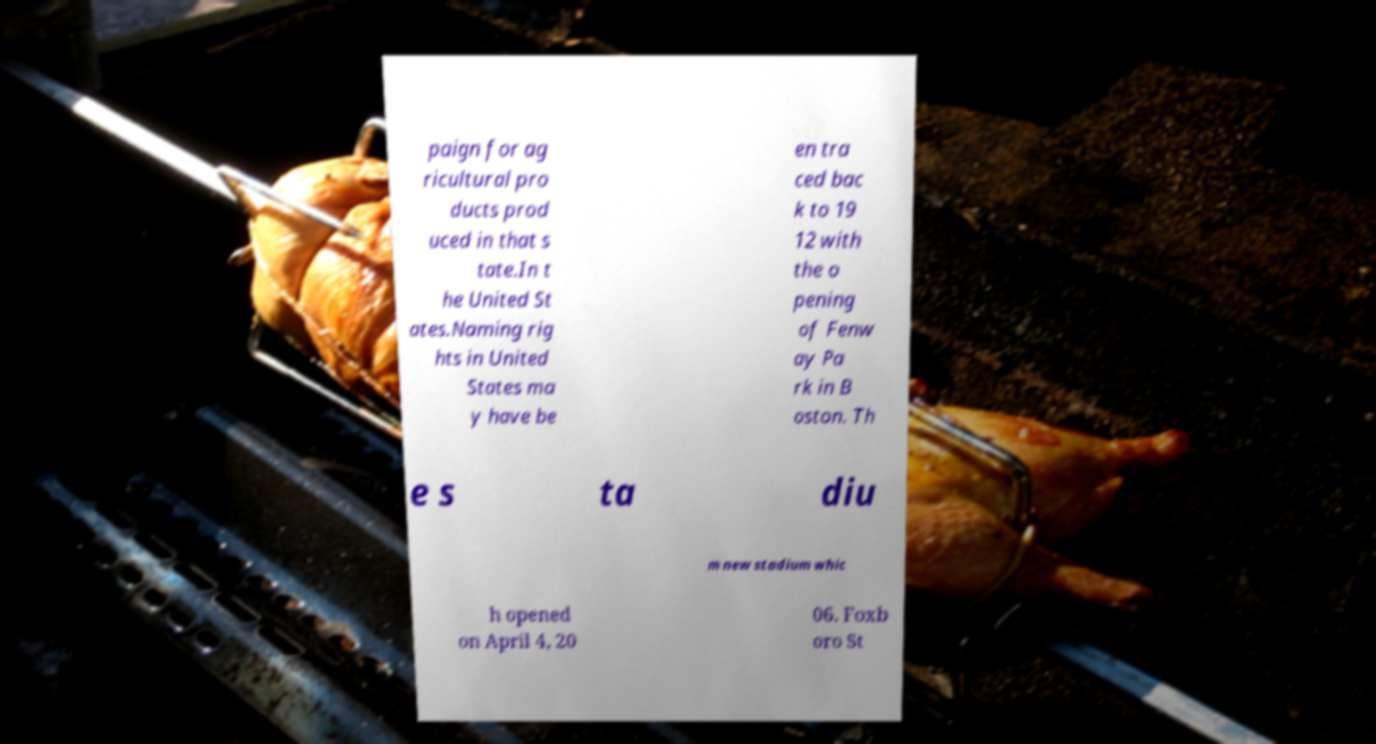Can you read and provide the text displayed in the image?This photo seems to have some interesting text. Can you extract and type it out for me? paign for ag ricultural pro ducts prod uced in that s tate.In t he United St ates.Naming rig hts in United States ma y have be en tra ced bac k to 19 12 with the o pening of Fenw ay Pa rk in B oston. Th e s ta diu m new stadium whic h opened on April 4, 20 06. Foxb oro St 